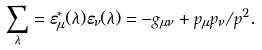Convert formula to latex. <formula><loc_0><loc_0><loc_500><loc_500>\sum _ { \lambda } = \varepsilon ^ { * } _ { \mu } ( \lambda ) \varepsilon _ { \nu } ( \lambda ) = - g _ { \mu \nu } + p _ { \mu } p _ { \nu } / p ^ { 2 } .</formula> 